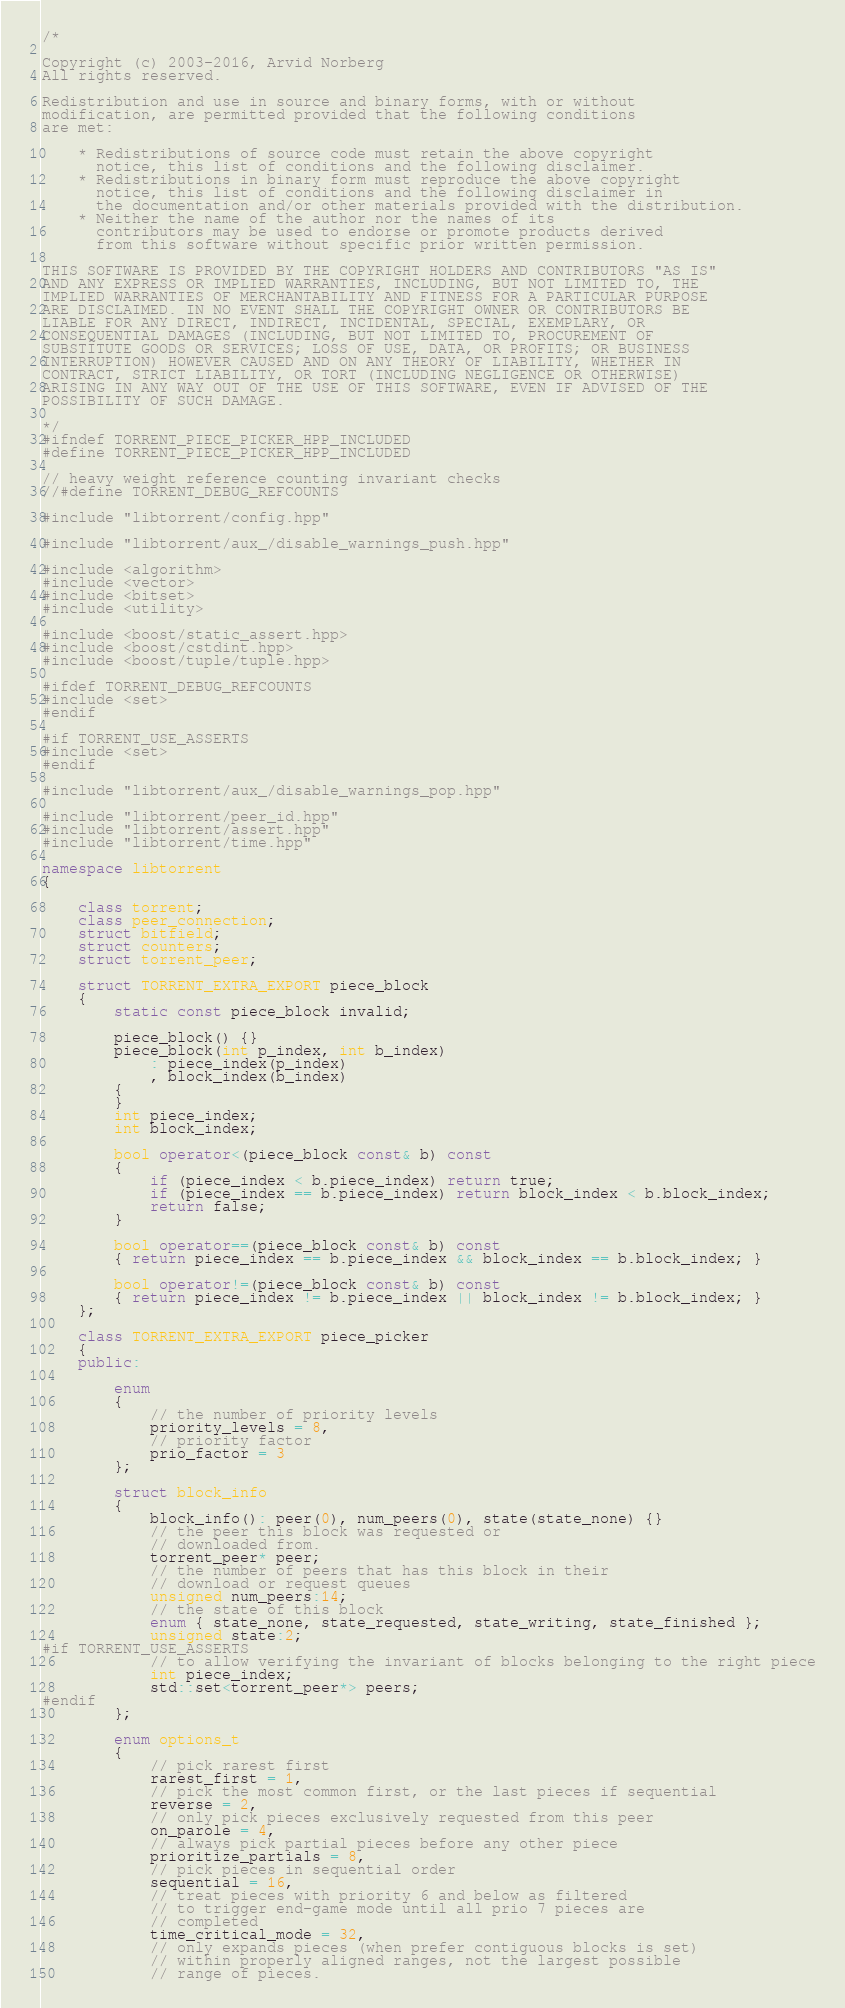Convert code to text. <code><loc_0><loc_0><loc_500><loc_500><_C++_>/*

Copyright (c) 2003-2016, Arvid Norberg
All rights reserved.

Redistribution and use in source and binary forms, with or without
modification, are permitted provided that the following conditions
are met:

    * Redistributions of source code must retain the above copyright
      notice, this list of conditions and the following disclaimer.
    * Redistributions in binary form must reproduce the above copyright
      notice, this list of conditions and the following disclaimer in
      the documentation and/or other materials provided with the distribution.
    * Neither the name of the author nor the names of its
      contributors may be used to endorse or promote products derived
      from this software without specific prior written permission.

THIS SOFTWARE IS PROVIDED BY THE COPYRIGHT HOLDERS AND CONTRIBUTORS "AS IS"
AND ANY EXPRESS OR IMPLIED WARRANTIES, INCLUDING, BUT NOT LIMITED TO, THE
IMPLIED WARRANTIES OF MERCHANTABILITY AND FITNESS FOR A PARTICULAR PURPOSE
ARE DISCLAIMED. IN NO EVENT SHALL THE COPYRIGHT OWNER OR CONTRIBUTORS BE
LIABLE FOR ANY DIRECT, INDIRECT, INCIDENTAL, SPECIAL, EXEMPLARY, OR
CONSEQUENTIAL DAMAGES (INCLUDING, BUT NOT LIMITED TO, PROCUREMENT OF
SUBSTITUTE GOODS OR SERVICES; LOSS OF USE, DATA, OR PROFITS; OR BUSINESS
INTERRUPTION) HOWEVER CAUSED AND ON ANY THEORY OF LIABILITY, WHETHER IN
CONTRACT, STRICT LIABILITY, OR TORT (INCLUDING NEGLIGENCE OR OTHERWISE)
ARISING IN ANY WAY OUT OF THE USE OF THIS SOFTWARE, EVEN IF ADVISED OF THE
POSSIBILITY OF SUCH DAMAGE.

*/
#ifndef TORRENT_PIECE_PICKER_HPP_INCLUDED
#define TORRENT_PIECE_PICKER_HPP_INCLUDED

// heavy weight reference counting invariant checks
//#define TORRENT_DEBUG_REFCOUNTS

#include "libtorrent/config.hpp"

#include "libtorrent/aux_/disable_warnings_push.hpp"

#include <algorithm>
#include <vector>
#include <bitset>
#include <utility>

#include <boost/static_assert.hpp>
#include <boost/cstdint.hpp>
#include <boost/tuple/tuple.hpp>

#ifdef TORRENT_DEBUG_REFCOUNTS
#include <set>
#endif

#if TORRENT_USE_ASSERTS
#include <set>
#endif

#include "libtorrent/aux_/disable_warnings_pop.hpp"

#include "libtorrent/peer_id.hpp"
#include "libtorrent/assert.hpp"
#include "libtorrent/time.hpp"

namespace libtorrent
{

	class torrent;
	class peer_connection;
	struct bitfield;
	struct counters;
	struct torrent_peer;

	struct TORRENT_EXTRA_EXPORT piece_block
	{
		static const piece_block invalid;

		piece_block() {}
		piece_block(int p_index, int b_index)
			: piece_index(p_index)
			, block_index(b_index)
		{
		}
		int piece_index;
		int block_index;

		bool operator<(piece_block const& b) const
		{
			if (piece_index < b.piece_index) return true;
			if (piece_index == b.piece_index) return block_index < b.block_index;
			return false;
		}

		bool operator==(piece_block const& b) const
		{ return piece_index == b.piece_index && block_index == b.block_index; }

		bool operator!=(piece_block const& b) const
		{ return piece_index != b.piece_index || block_index != b.block_index; }
	};

	class TORRENT_EXTRA_EXPORT piece_picker
	{
	public:

		enum
		{
			// the number of priority levels
			priority_levels = 8,
			// priority factor
			prio_factor = 3
		};

		struct block_info
		{
			block_info(): peer(0), num_peers(0), state(state_none) {}
			// the peer this block was requested or
			// downloaded from.
			torrent_peer* peer;
			// the number of peers that has this block in their
			// download or request queues
			unsigned num_peers:14;
			// the state of this block
			enum { state_none, state_requested, state_writing, state_finished };
			unsigned state:2;
#if TORRENT_USE_ASSERTS
			// to allow verifying the invariant of blocks belonging to the right piece
			int piece_index;
			std::set<torrent_peer*> peers;
#endif
		};

		enum options_t
		{
			// pick rarest first
			rarest_first = 1,
			// pick the most common first, or the last pieces if sequential
			reverse = 2,
			// only pick pieces exclusively requested from this peer
			on_parole = 4,
			// always pick partial pieces before any other piece
			prioritize_partials = 8,
			// pick pieces in sequential order
			sequential = 16,
			// treat pieces with priority 6 and below as filtered
			// to trigger end-game mode until all prio 7 pieces are
			// completed
			time_critical_mode = 32,
			// only expands pieces (when prefer contiguous blocks is set)
			// within properly aligned ranges, not the largest possible
			// range of pieces.</code> 